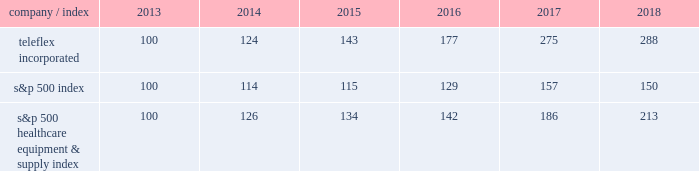Part a0ii item a05 .
Market for registrant 2019s common equity , related stockholder matters and issuer purchases of equity securities our common stock is listed on the new york stock exchange under the symbol 201ctfx . 201d as of february 19 , 2019 , we had 473 holders of record of our common stock .
A substantially greater number of holders of our common stock are beneficial owners whose shares are held by brokers and other financial institutions for the accounts of beneficial owners .
Stock performance graph the following graph provides a comparison of five year cumulative total stockholder returns of teleflex common stock , the standard a0& poor 2019s ( s&p ) 500 stock index and the s&p 500 healthcare equipment & supply index .
The annual changes for the five-year period shown on the graph are based on the assumption that $ 100 had been invested in teleflex common stock and each index on december a031 , 2013 and that all dividends were reinvested .
Market performance .
S&p 500 healthcare equipment & supply index 100 126 134 142 186 213 .
What is the range of market performance for the s&p 500 index from 2013-2018? 
Computations: (157 - 100)
Answer: 57.0. 